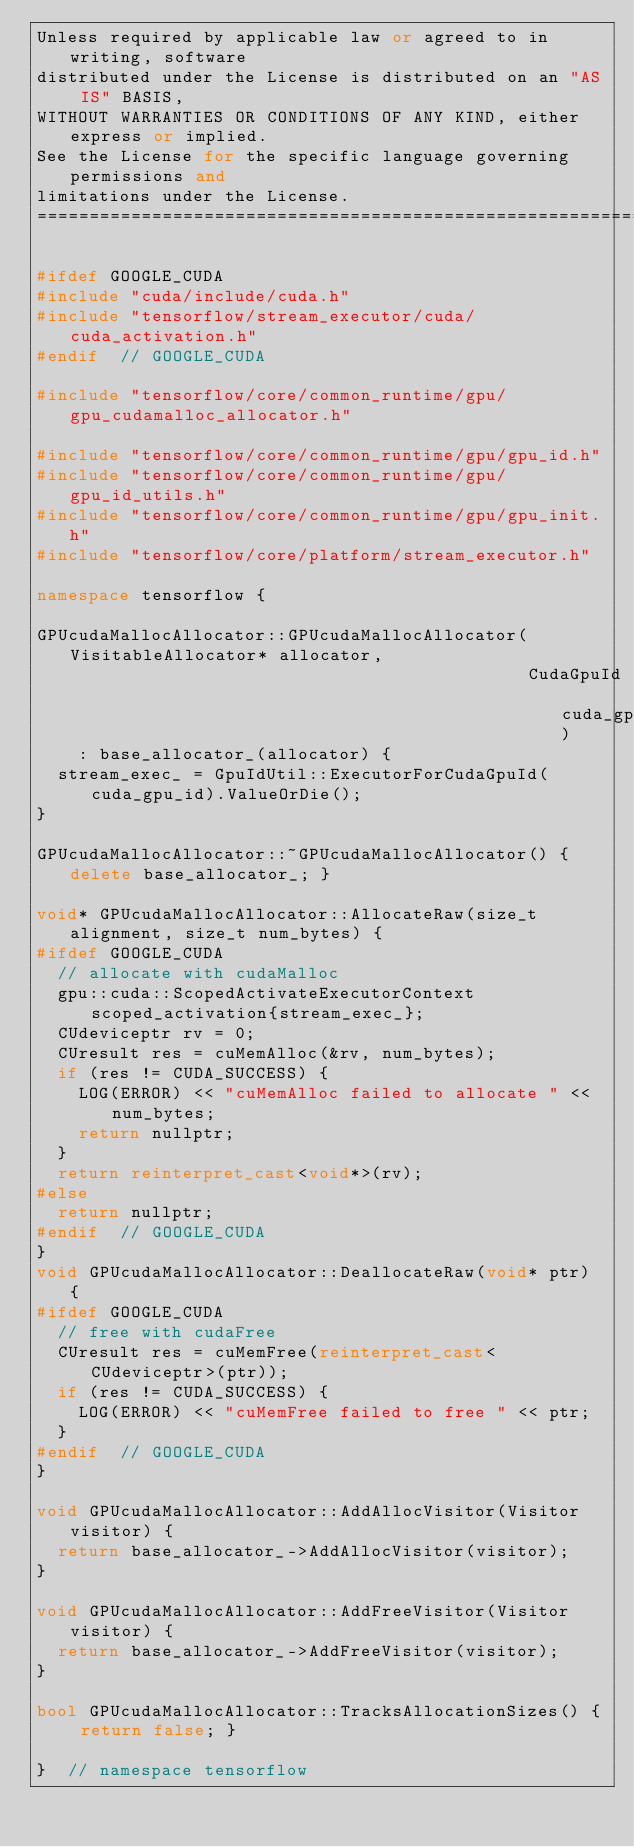Convert code to text. <code><loc_0><loc_0><loc_500><loc_500><_C++_>Unless required by applicable law or agreed to in writing, software
distributed under the License is distributed on an "AS IS" BASIS,
WITHOUT WARRANTIES OR CONDITIONS OF ANY KIND, either express or implied.
See the License for the specific language governing permissions and
limitations under the License.
==============================================================================*/

#ifdef GOOGLE_CUDA
#include "cuda/include/cuda.h"
#include "tensorflow/stream_executor/cuda/cuda_activation.h"
#endif  // GOOGLE_CUDA

#include "tensorflow/core/common_runtime/gpu/gpu_cudamalloc_allocator.h"

#include "tensorflow/core/common_runtime/gpu/gpu_id.h"
#include "tensorflow/core/common_runtime/gpu/gpu_id_utils.h"
#include "tensorflow/core/common_runtime/gpu/gpu_init.h"
#include "tensorflow/core/platform/stream_executor.h"

namespace tensorflow {

GPUcudaMallocAllocator::GPUcudaMallocAllocator(VisitableAllocator* allocator,
                                               CudaGpuId cuda_gpu_id)
    : base_allocator_(allocator) {
  stream_exec_ = GpuIdUtil::ExecutorForCudaGpuId(cuda_gpu_id).ValueOrDie();
}

GPUcudaMallocAllocator::~GPUcudaMallocAllocator() { delete base_allocator_; }

void* GPUcudaMallocAllocator::AllocateRaw(size_t alignment, size_t num_bytes) {
#ifdef GOOGLE_CUDA
  // allocate with cudaMalloc
  gpu::cuda::ScopedActivateExecutorContext scoped_activation{stream_exec_};
  CUdeviceptr rv = 0;
  CUresult res = cuMemAlloc(&rv, num_bytes);
  if (res != CUDA_SUCCESS) {
    LOG(ERROR) << "cuMemAlloc failed to allocate " << num_bytes;
    return nullptr;
  }
  return reinterpret_cast<void*>(rv);
#else
  return nullptr;
#endif  // GOOGLE_CUDA
}
void GPUcudaMallocAllocator::DeallocateRaw(void* ptr) {
#ifdef GOOGLE_CUDA
  // free with cudaFree
  CUresult res = cuMemFree(reinterpret_cast<CUdeviceptr>(ptr));
  if (res != CUDA_SUCCESS) {
    LOG(ERROR) << "cuMemFree failed to free " << ptr;
  }
#endif  // GOOGLE_CUDA
}

void GPUcudaMallocAllocator::AddAllocVisitor(Visitor visitor) {
  return base_allocator_->AddAllocVisitor(visitor);
}

void GPUcudaMallocAllocator::AddFreeVisitor(Visitor visitor) {
  return base_allocator_->AddFreeVisitor(visitor);
}

bool GPUcudaMallocAllocator::TracksAllocationSizes() { return false; }

}  // namespace tensorflow
</code> 